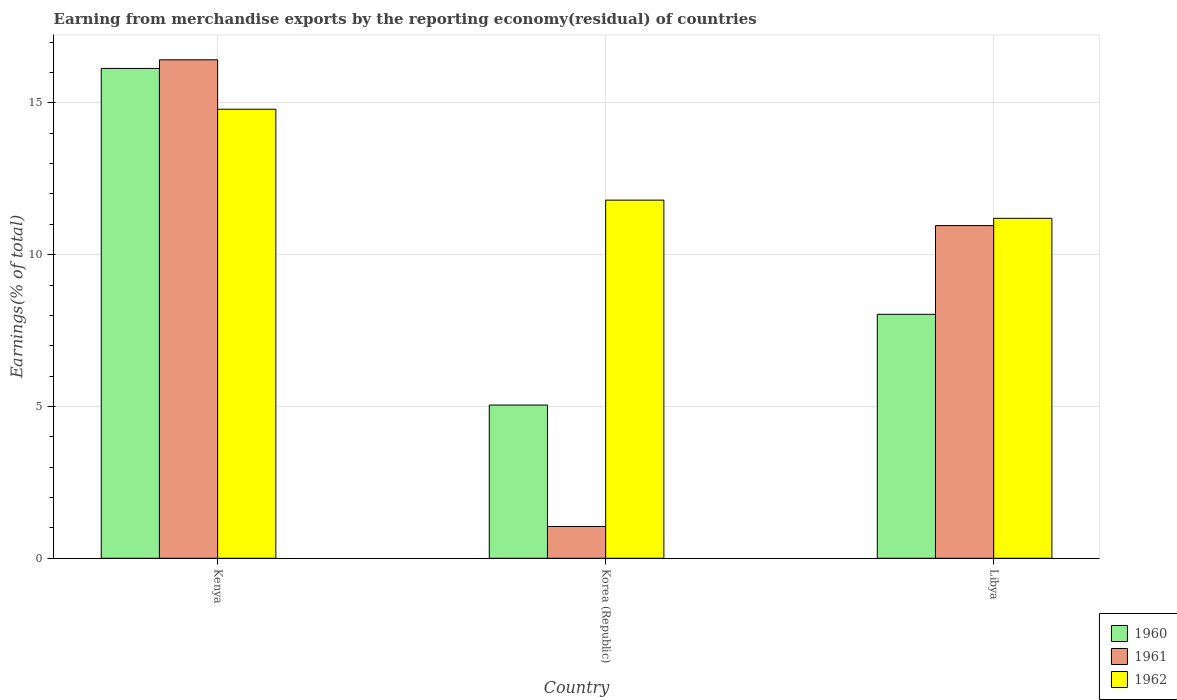How many groups of bars are there?
Provide a succinct answer. 3. Are the number of bars per tick equal to the number of legend labels?
Ensure brevity in your answer.  Yes. How many bars are there on the 1st tick from the right?
Provide a succinct answer. 3. What is the label of the 2nd group of bars from the left?
Ensure brevity in your answer.  Korea (Republic). In how many cases, is the number of bars for a given country not equal to the number of legend labels?
Ensure brevity in your answer.  0. What is the percentage of amount earned from merchandise exports in 1961 in Libya?
Your answer should be very brief. 10.96. Across all countries, what is the maximum percentage of amount earned from merchandise exports in 1960?
Give a very brief answer. 16.13. Across all countries, what is the minimum percentage of amount earned from merchandise exports in 1961?
Your answer should be compact. 1.05. In which country was the percentage of amount earned from merchandise exports in 1962 maximum?
Give a very brief answer. Kenya. In which country was the percentage of amount earned from merchandise exports in 1962 minimum?
Offer a very short reply. Libya. What is the total percentage of amount earned from merchandise exports in 1960 in the graph?
Provide a short and direct response. 29.22. What is the difference between the percentage of amount earned from merchandise exports in 1960 in Korea (Republic) and that in Libya?
Offer a very short reply. -2.99. What is the difference between the percentage of amount earned from merchandise exports in 1960 in Libya and the percentage of amount earned from merchandise exports in 1961 in Kenya?
Provide a short and direct response. -8.38. What is the average percentage of amount earned from merchandise exports in 1961 per country?
Provide a succinct answer. 9.48. What is the difference between the percentage of amount earned from merchandise exports of/in 1962 and percentage of amount earned from merchandise exports of/in 1960 in Libya?
Offer a very short reply. 3.16. In how many countries, is the percentage of amount earned from merchandise exports in 1962 greater than 2 %?
Your answer should be very brief. 3. What is the ratio of the percentage of amount earned from merchandise exports in 1961 in Kenya to that in Korea (Republic)?
Provide a succinct answer. 15.68. Is the difference between the percentage of amount earned from merchandise exports in 1962 in Kenya and Libya greater than the difference between the percentage of amount earned from merchandise exports in 1960 in Kenya and Libya?
Offer a very short reply. No. What is the difference between the highest and the second highest percentage of amount earned from merchandise exports in 1961?
Keep it short and to the point. 15.37. What is the difference between the highest and the lowest percentage of amount earned from merchandise exports in 1962?
Your response must be concise. 3.59. In how many countries, is the percentage of amount earned from merchandise exports in 1960 greater than the average percentage of amount earned from merchandise exports in 1960 taken over all countries?
Give a very brief answer. 1. Is the sum of the percentage of amount earned from merchandise exports in 1961 in Korea (Republic) and Libya greater than the maximum percentage of amount earned from merchandise exports in 1960 across all countries?
Provide a short and direct response. No. What does the 2nd bar from the left in Libya represents?
Give a very brief answer. 1961. How many bars are there?
Offer a very short reply. 9. Are all the bars in the graph horizontal?
Offer a very short reply. No. Are the values on the major ticks of Y-axis written in scientific E-notation?
Keep it short and to the point. No. How many legend labels are there?
Give a very brief answer. 3. How are the legend labels stacked?
Your answer should be very brief. Vertical. What is the title of the graph?
Provide a succinct answer. Earning from merchandise exports by the reporting economy(residual) of countries. What is the label or title of the Y-axis?
Ensure brevity in your answer.  Earnings(% of total). What is the Earnings(% of total) in 1960 in Kenya?
Ensure brevity in your answer.  16.13. What is the Earnings(% of total) in 1961 in Kenya?
Keep it short and to the point. 16.42. What is the Earnings(% of total) in 1962 in Kenya?
Offer a very short reply. 14.79. What is the Earnings(% of total) in 1960 in Korea (Republic)?
Your response must be concise. 5.05. What is the Earnings(% of total) of 1961 in Korea (Republic)?
Keep it short and to the point. 1.05. What is the Earnings(% of total) of 1962 in Korea (Republic)?
Your answer should be very brief. 11.8. What is the Earnings(% of total) of 1960 in Libya?
Keep it short and to the point. 8.04. What is the Earnings(% of total) of 1961 in Libya?
Offer a terse response. 10.96. What is the Earnings(% of total) in 1962 in Libya?
Offer a terse response. 11.2. Across all countries, what is the maximum Earnings(% of total) of 1960?
Your answer should be very brief. 16.13. Across all countries, what is the maximum Earnings(% of total) in 1961?
Offer a terse response. 16.42. Across all countries, what is the maximum Earnings(% of total) in 1962?
Provide a short and direct response. 14.79. Across all countries, what is the minimum Earnings(% of total) of 1960?
Make the answer very short. 5.05. Across all countries, what is the minimum Earnings(% of total) in 1961?
Offer a very short reply. 1.05. Across all countries, what is the minimum Earnings(% of total) of 1962?
Your answer should be very brief. 11.2. What is the total Earnings(% of total) in 1960 in the graph?
Your answer should be very brief. 29.22. What is the total Earnings(% of total) in 1961 in the graph?
Your response must be concise. 28.43. What is the total Earnings(% of total) in 1962 in the graph?
Make the answer very short. 37.78. What is the difference between the Earnings(% of total) in 1960 in Kenya and that in Korea (Republic)?
Give a very brief answer. 11.09. What is the difference between the Earnings(% of total) of 1961 in Kenya and that in Korea (Republic)?
Provide a succinct answer. 15.37. What is the difference between the Earnings(% of total) in 1962 in Kenya and that in Korea (Republic)?
Ensure brevity in your answer.  2.99. What is the difference between the Earnings(% of total) of 1960 in Kenya and that in Libya?
Your answer should be compact. 8.1. What is the difference between the Earnings(% of total) of 1961 in Kenya and that in Libya?
Offer a terse response. 5.46. What is the difference between the Earnings(% of total) of 1962 in Kenya and that in Libya?
Offer a terse response. 3.59. What is the difference between the Earnings(% of total) in 1960 in Korea (Republic) and that in Libya?
Keep it short and to the point. -2.99. What is the difference between the Earnings(% of total) of 1961 in Korea (Republic) and that in Libya?
Your response must be concise. -9.91. What is the difference between the Earnings(% of total) of 1962 in Korea (Republic) and that in Libya?
Give a very brief answer. 0.6. What is the difference between the Earnings(% of total) in 1960 in Kenya and the Earnings(% of total) in 1961 in Korea (Republic)?
Keep it short and to the point. 15.09. What is the difference between the Earnings(% of total) in 1960 in Kenya and the Earnings(% of total) in 1962 in Korea (Republic)?
Make the answer very short. 4.34. What is the difference between the Earnings(% of total) in 1961 in Kenya and the Earnings(% of total) in 1962 in Korea (Republic)?
Offer a very short reply. 4.62. What is the difference between the Earnings(% of total) in 1960 in Kenya and the Earnings(% of total) in 1961 in Libya?
Make the answer very short. 5.18. What is the difference between the Earnings(% of total) of 1960 in Kenya and the Earnings(% of total) of 1962 in Libya?
Make the answer very short. 4.94. What is the difference between the Earnings(% of total) of 1961 in Kenya and the Earnings(% of total) of 1962 in Libya?
Ensure brevity in your answer.  5.22. What is the difference between the Earnings(% of total) of 1960 in Korea (Republic) and the Earnings(% of total) of 1961 in Libya?
Ensure brevity in your answer.  -5.91. What is the difference between the Earnings(% of total) in 1960 in Korea (Republic) and the Earnings(% of total) in 1962 in Libya?
Give a very brief answer. -6.15. What is the difference between the Earnings(% of total) of 1961 in Korea (Republic) and the Earnings(% of total) of 1962 in Libya?
Give a very brief answer. -10.15. What is the average Earnings(% of total) in 1960 per country?
Give a very brief answer. 9.74. What is the average Earnings(% of total) of 1961 per country?
Give a very brief answer. 9.48. What is the average Earnings(% of total) in 1962 per country?
Ensure brevity in your answer.  12.6. What is the difference between the Earnings(% of total) in 1960 and Earnings(% of total) in 1961 in Kenya?
Ensure brevity in your answer.  -0.28. What is the difference between the Earnings(% of total) of 1960 and Earnings(% of total) of 1962 in Kenya?
Give a very brief answer. 1.34. What is the difference between the Earnings(% of total) of 1961 and Earnings(% of total) of 1962 in Kenya?
Make the answer very short. 1.63. What is the difference between the Earnings(% of total) of 1960 and Earnings(% of total) of 1961 in Korea (Republic)?
Give a very brief answer. 4. What is the difference between the Earnings(% of total) of 1960 and Earnings(% of total) of 1962 in Korea (Republic)?
Give a very brief answer. -6.75. What is the difference between the Earnings(% of total) of 1961 and Earnings(% of total) of 1962 in Korea (Republic)?
Make the answer very short. -10.75. What is the difference between the Earnings(% of total) in 1960 and Earnings(% of total) in 1961 in Libya?
Your answer should be very brief. -2.92. What is the difference between the Earnings(% of total) of 1960 and Earnings(% of total) of 1962 in Libya?
Your response must be concise. -3.16. What is the difference between the Earnings(% of total) in 1961 and Earnings(% of total) in 1962 in Libya?
Ensure brevity in your answer.  -0.24. What is the ratio of the Earnings(% of total) in 1960 in Kenya to that in Korea (Republic)?
Provide a succinct answer. 3.2. What is the ratio of the Earnings(% of total) in 1961 in Kenya to that in Korea (Republic)?
Your answer should be compact. 15.68. What is the ratio of the Earnings(% of total) in 1962 in Kenya to that in Korea (Republic)?
Offer a terse response. 1.25. What is the ratio of the Earnings(% of total) of 1960 in Kenya to that in Libya?
Your response must be concise. 2.01. What is the ratio of the Earnings(% of total) of 1961 in Kenya to that in Libya?
Your response must be concise. 1.5. What is the ratio of the Earnings(% of total) in 1962 in Kenya to that in Libya?
Make the answer very short. 1.32. What is the ratio of the Earnings(% of total) in 1960 in Korea (Republic) to that in Libya?
Your response must be concise. 0.63. What is the ratio of the Earnings(% of total) in 1961 in Korea (Republic) to that in Libya?
Your response must be concise. 0.1. What is the ratio of the Earnings(% of total) in 1962 in Korea (Republic) to that in Libya?
Offer a very short reply. 1.05. What is the difference between the highest and the second highest Earnings(% of total) of 1960?
Offer a very short reply. 8.1. What is the difference between the highest and the second highest Earnings(% of total) in 1961?
Ensure brevity in your answer.  5.46. What is the difference between the highest and the second highest Earnings(% of total) of 1962?
Provide a short and direct response. 2.99. What is the difference between the highest and the lowest Earnings(% of total) in 1960?
Make the answer very short. 11.09. What is the difference between the highest and the lowest Earnings(% of total) of 1961?
Keep it short and to the point. 15.37. What is the difference between the highest and the lowest Earnings(% of total) in 1962?
Keep it short and to the point. 3.59. 